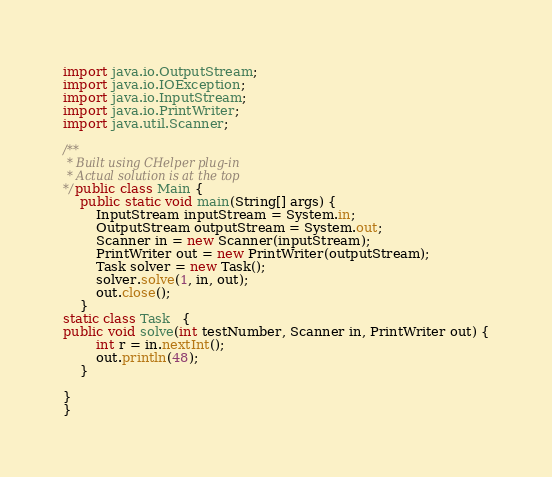<code> <loc_0><loc_0><loc_500><loc_500><_Java_>import java.io.OutputStream;
import java.io.IOException;
import java.io.InputStream;
import java.io.PrintWriter;
import java.util.Scanner;

/**
 * Built using CHelper plug-in
 * Actual solution is at the top
*/public class Main {
	public static void main(String[] args) {
		InputStream inputStream = System.in;
		OutputStream outputStream = System.out;
		Scanner in = new Scanner(inputStream);
		PrintWriter out = new PrintWriter(outputStream);
		Task solver = new Task();
		solver.solve(1, in, out);
		out.close();
	}
static class Task   {
public void solve(int testNumber, Scanner in, PrintWriter out) {
        int r = in.nextInt();
        out.println(48);
    }

}
}

</code> 